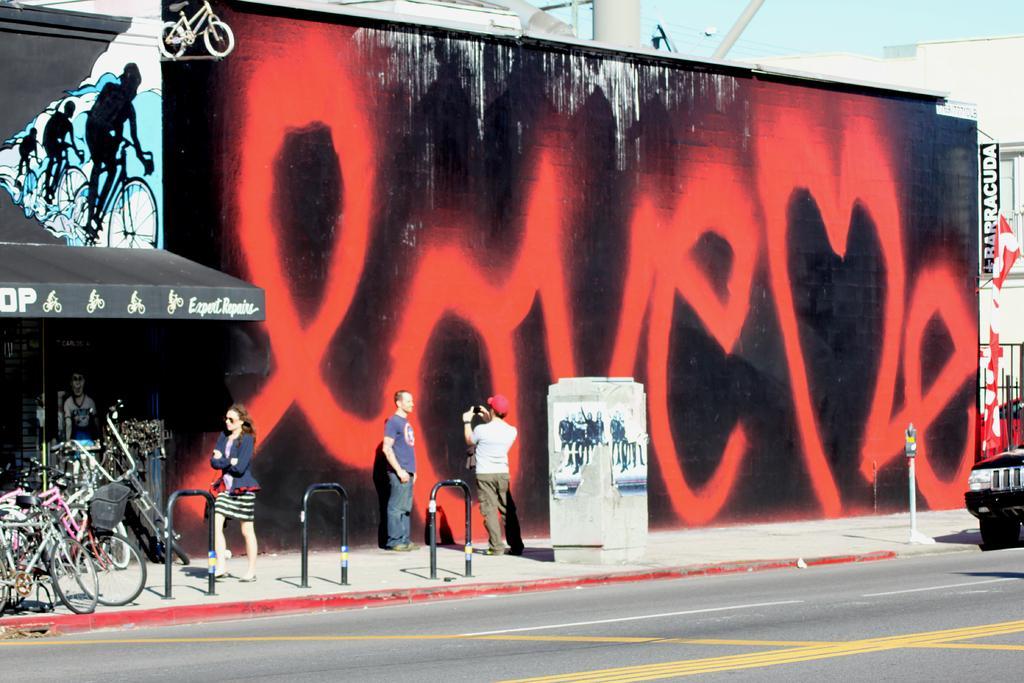Describe this image in one or two sentences. In the image we can see a wall and there is a painting on the wall. There are people standing and walking, they are wearing clothes. There is a road, on the road there is a vehicle. This is a pole, bicycle, electric wires, buildings, poster and a sky. 